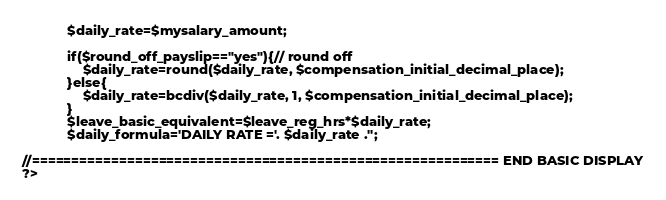Convert code to text. <code><loc_0><loc_0><loc_500><loc_500><_PHP_>            $daily_rate=$mysalary_amount;

            if($round_off_payslip=="yes"){// round off
                $daily_rate=round($daily_rate, $compensation_initial_decimal_place);
            }else{
                $daily_rate=bcdiv($daily_rate, 1, $compensation_initial_decimal_place); 
            }
            $leave_basic_equivalent=$leave_reg_hrs*$daily_rate;
            $daily_formula='DAILY RATE ='. $daily_rate .'';

//=========================================================== END BASIC DISPLAY
?></code> 